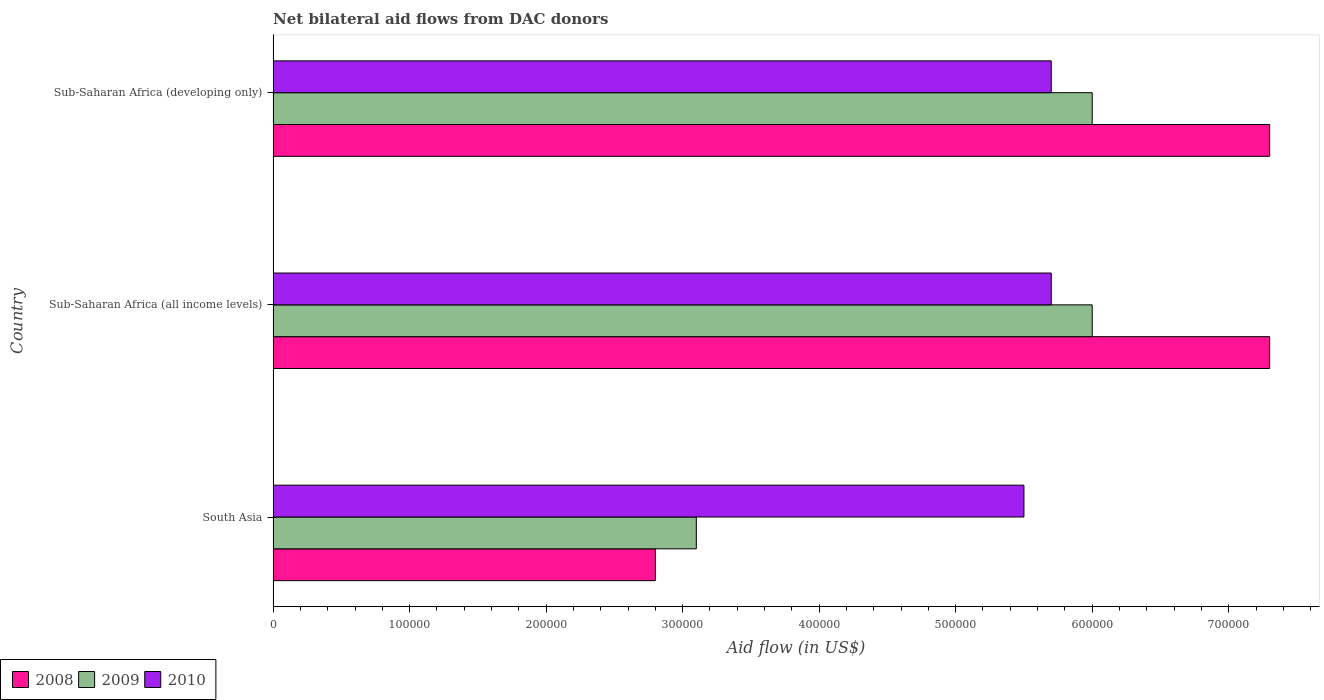How many different coloured bars are there?
Offer a very short reply. 3. How many groups of bars are there?
Provide a succinct answer. 3. Are the number of bars per tick equal to the number of legend labels?
Your response must be concise. Yes. How many bars are there on the 2nd tick from the top?
Make the answer very short. 3. In how many cases, is the number of bars for a given country not equal to the number of legend labels?
Give a very brief answer. 0. What is the net bilateral aid flow in 2010 in Sub-Saharan Africa (all income levels)?
Give a very brief answer. 5.70e+05. In which country was the net bilateral aid flow in 2008 maximum?
Provide a short and direct response. Sub-Saharan Africa (all income levels). In which country was the net bilateral aid flow in 2009 minimum?
Provide a short and direct response. South Asia. What is the total net bilateral aid flow in 2010 in the graph?
Make the answer very short. 1.69e+06. What is the difference between the net bilateral aid flow in 2010 in South Asia and that in Sub-Saharan Africa (all income levels)?
Give a very brief answer. -2.00e+04. What is the average net bilateral aid flow in 2010 per country?
Make the answer very short. 5.63e+05. What is the difference between the net bilateral aid flow in 2008 and net bilateral aid flow in 2010 in Sub-Saharan Africa (all income levels)?
Give a very brief answer. 1.60e+05. What is the ratio of the net bilateral aid flow in 2009 in Sub-Saharan Africa (all income levels) to that in Sub-Saharan Africa (developing only)?
Your answer should be compact. 1. Is the difference between the net bilateral aid flow in 2008 in South Asia and Sub-Saharan Africa (developing only) greater than the difference between the net bilateral aid flow in 2010 in South Asia and Sub-Saharan Africa (developing only)?
Your response must be concise. No. In how many countries, is the net bilateral aid flow in 2009 greater than the average net bilateral aid flow in 2009 taken over all countries?
Give a very brief answer. 2. Is the sum of the net bilateral aid flow in 2010 in South Asia and Sub-Saharan Africa (developing only) greater than the maximum net bilateral aid flow in 2009 across all countries?
Offer a very short reply. Yes. What is the difference between two consecutive major ticks on the X-axis?
Ensure brevity in your answer.  1.00e+05. Are the values on the major ticks of X-axis written in scientific E-notation?
Your answer should be very brief. No. How many legend labels are there?
Make the answer very short. 3. How are the legend labels stacked?
Give a very brief answer. Horizontal. What is the title of the graph?
Your answer should be compact. Net bilateral aid flows from DAC donors. Does "2006" appear as one of the legend labels in the graph?
Give a very brief answer. No. What is the label or title of the X-axis?
Make the answer very short. Aid flow (in US$). What is the Aid flow (in US$) in 2009 in South Asia?
Ensure brevity in your answer.  3.10e+05. What is the Aid flow (in US$) of 2008 in Sub-Saharan Africa (all income levels)?
Provide a succinct answer. 7.30e+05. What is the Aid flow (in US$) in 2009 in Sub-Saharan Africa (all income levels)?
Your answer should be very brief. 6.00e+05. What is the Aid flow (in US$) in 2010 in Sub-Saharan Africa (all income levels)?
Your response must be concise. 5.70e+05. What is the Aid flow (in US$) of 2008 in Sub-Saharan Africa (developing only)?
Keep it short and to the point. 7.30e+05. What is the Aid flow (in US$) in 2010 in Sub-Saharan Africa (developing only)?
Provide a short and direct response. 5.70e+05. Across all countries, what is the maximum Aid flow (in US$) of 2008?
Ensure brevity in your answer.  7.30e+05. Across all countries, what is the maximum Aid flow (in US$) in 2009?
Provide a short and direct response. 6.00e+05. Across all countries, what is the maximum Aid flow (in US$) of 2010?
Your answer should be very brief. 5.70e+05. Across all countries, what is the minimum Aid flow (in US$) of 2009?
Keep it short and to the point. 3.10e+05. Across all countries, what is the minimum Aid flow (in US$) in 2010?
Give a very brief answer. 5.50e+05. What is the total Aid flow (in US$) in 2008 in the graph?
Your answer should be very brief. 1.74e+06. What is the total Aid flow (in US$) in 2009 in the graph?
Offer a terse response. 1.51e+06. What is the total Aid flow (in US$) of 2010 in the graph?
Keep it short and to the point. 1.69e+06. What is the difference between the Aid flow (in US$) of 2008 in South Asia and that in Sub-Saharan Africa (all income levels)?
Your answer should be compact. -4.50e+05. What is the difference between the Aid flow (in US$) of 2008 in South Asia and that in Sub-Saharan Africa (developing only)?
Your response must be concise. -4.50e+05. What is the difference between the Aid flow (in US$) of 2008 in Sub-Saharan Africa (all income levels) and that in Sub-Saharan Africa (developing only)?
Offer a terse response. 0. What is the difference between the Aid flow (in US$) of 2009 in Sub-Saharan Africa (all income levels) and that in Sub-Saharan Africa (developing only)?
Provide a succinct answer. 0. What is the difference between the Aid flow (in US$) of 2010 in Sub-Saharan Africa (all income levels) and that in Sub-Saharan Africa (developing only)?
Offer a terse response. 0. What is the difference between the Aid flow (in US$) of 2008 in South Asia and the Aid flow (in US$) of 2009 in Sub-Saharan Africa (all income levels)?
Your answer should be compact. -3.20e+05. What is the difference between the Aid flow (in US$) of 2009 in South Asia and the Aid flow (in US$) of 2010 in Sub-Saharan Africa (all income levels)?
Provide a short and direct response. -2.60e+05. What is the difference between the Aid flow (in US$) of 2008 in South Asia and the Aid flow (in US$) of 2009 in Sub-Saharan Africa (developing only)?
Keep it short and to the point. -3.20e+05. What is the average Aid flow (in US$) of 2008 per country?
Your response must be concise. 5.80e+05. What is the average Aid flow (in US$) of 2009 per country?
Your answer should be compact. 5.03e+05. What is the average Aid flow (in US$) in 2010 per country?
Offer a very short reply. 5.63e+05. What is the difference between the Aid flow (in US$) in 2008 and Aid flow (in US$) in 2009 in South Asia?
Keep it short and to the point. -3.00e+04. What is the difference between the Aid flow (in US$) in 2009 and Aid flow (in US$) in 2010 in South Asia?
Keep it short and to the point. -2.40e+05. What is the difference between the Aid flow (in US$) of 2008 and Aid flow (in US$) of 2009 in Sub-Saharan Africa (all income levels)?
Your answer should be compact. 1.30e+05. What is the difference between the Aid flow (in US$) in 2009 and Aid flow (in US$) in 2010 in Sub-Saharan Africa (all income levels)?
Your response must be concise. 3.00e+04. What is the difference between the Aid flow (in US$) in 2008 and Aid flow (in US$) in 2009 in Sub-Saharan Africa (developing only)?
Keep it short and to the point. 1.30e+05. What is the ratio of the Aid flow (in US$) of 2008 in South Asia to that in Sub-Saharan Africa (all income levels)?
Keep it short and to the point. 0.38. What is the ratio of the Aid flow (in US$) in 2009 in South Asia to that in Sub-Saharan Africa (all income levels)?
Keep it short and to the point. 0.52. What is the ratio of the Aid flow (in US$) of 2010 in South Asia to that in Sub-Saharan Africa (all income levels)?
Make the answer very short. 0.96. What is the ratio of the Aid flow (in US$) in 2008 in South Asia to that in Sub-Saharan Africa (developing only)?
Your response must be concise. 0.38. What is the ratio of the Aid flow (in US$) in 2009 in South Asia to that in Sub-Saharan Africa (developing only)?
Your answer should be compact. 0.52. What is the ratio of the Aid flow (in US$) of 2010 in South Asia to that in Sub-Saharan Africa (developing only)?
Give a very brief answer. 0.96. What is the ratio of the Aid flow (in US$) of 2009 in Sub-Saharan Africa (all income levels) to that in Sub-Saharan Africa (developing only)?
Offer a very short reply. 1. What is the ratio of the Aid flow (in US$) of 2010 in Sub-Saharan Africa (all income levels) to that in Sub-Saharan Africa (developing only)?
Your answer should be very brief. 1. What is the difference between the highest and the second highest Aid flow (in US$) in 2008?
Offer a terse response. 0. What is the difference between the highest and the second highest Aid flow (in US$) in 2009?
Ensure brevity in your answer.  0. What is the difference between the highest and the second highest Aid flow (in US$) in 2010?
Your answer should be very brief. 0. 